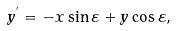Convert formula to latex. <formula><loc_0><loc_0><loc_500><loc_500>y ^ { ^ { \prime } } = - x \sin \varepsilon + y \cos \varepsilon ,</formula> 